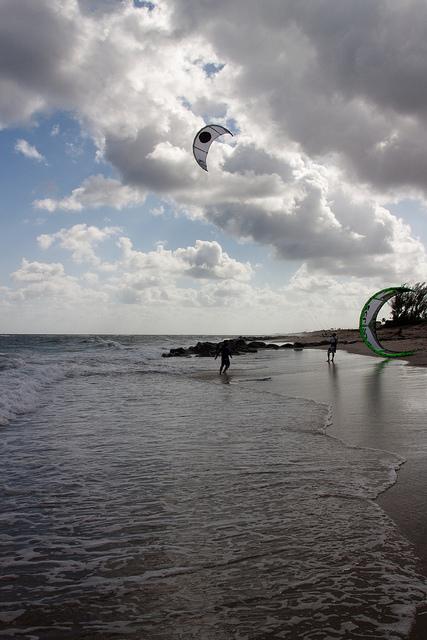Is this person dry?
Concise answer only. No. What is being flown?
Give a very brief answer. Kite. Are they near the water or inland?
Quick response, please. Water. What kind of day is this?
Be succinct. Cloudy. 